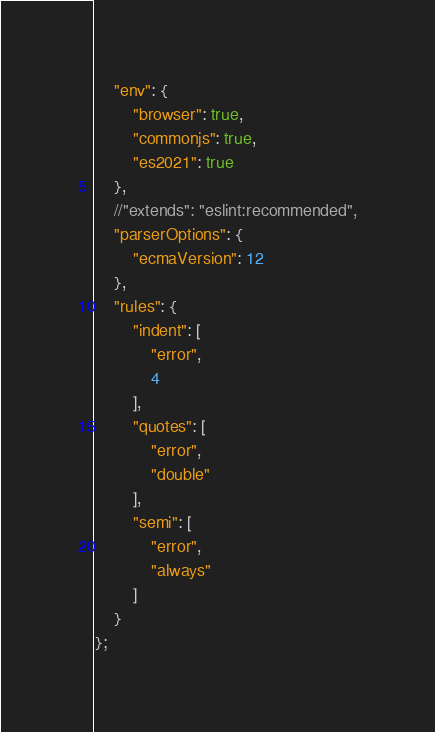Convert code to text. <code><loc_0><loc_0><loc_500><loc_500><_JavaScript_>    "env": {
        "browser": true,
        "commonjs": true,
        "es2021": true
    },
    //"extends": "eslint:recommended",
    "parserOptions": {
        "ecmaVersion": 12
    },
    "rules": {
        "indent": [
            "error",
            4
        ],
        "quotes": [
            "error",
            "double"
        ],
        "semi": [
            "error",
            "always"
        ]
    }
};
</code> 